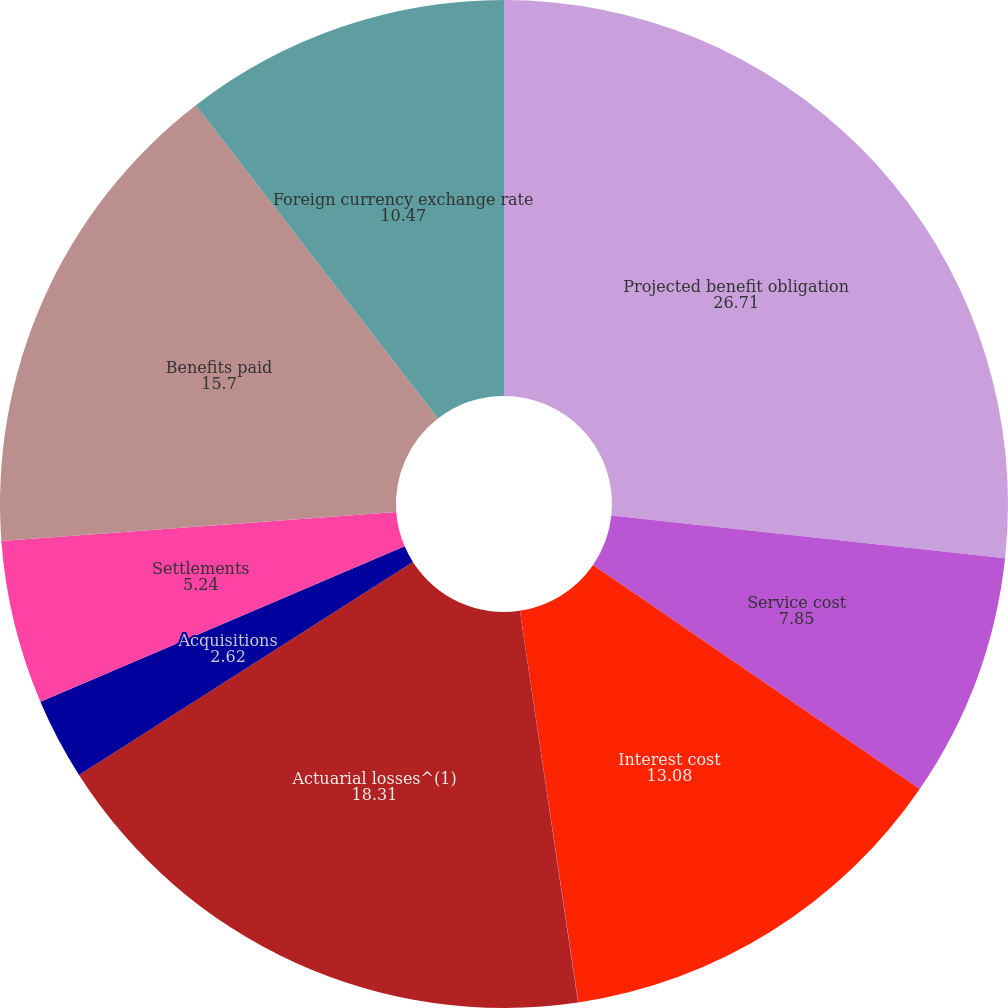<chart> <loc_0><loc_0><loc_500><loc_500><pie_chart><fcel>Projected benefit obligation<fcel>Service cost<fcel>Interest cost<fcel>Participant contributions<fcel>Actuarial losses^(1)<fcel>Acquisitions<fcel>Settlements<fcel>Benefits paid<fcel>Foreign currency exchange rate<nl><fcel>26.71%<fcel>7.85%<fcel>13.08%<fcel>0.01%<fcel>18.31%<fcel>2.62%<fcel>5.24%<fcel>15.7%<fcel>10.47%<nl></chart> 